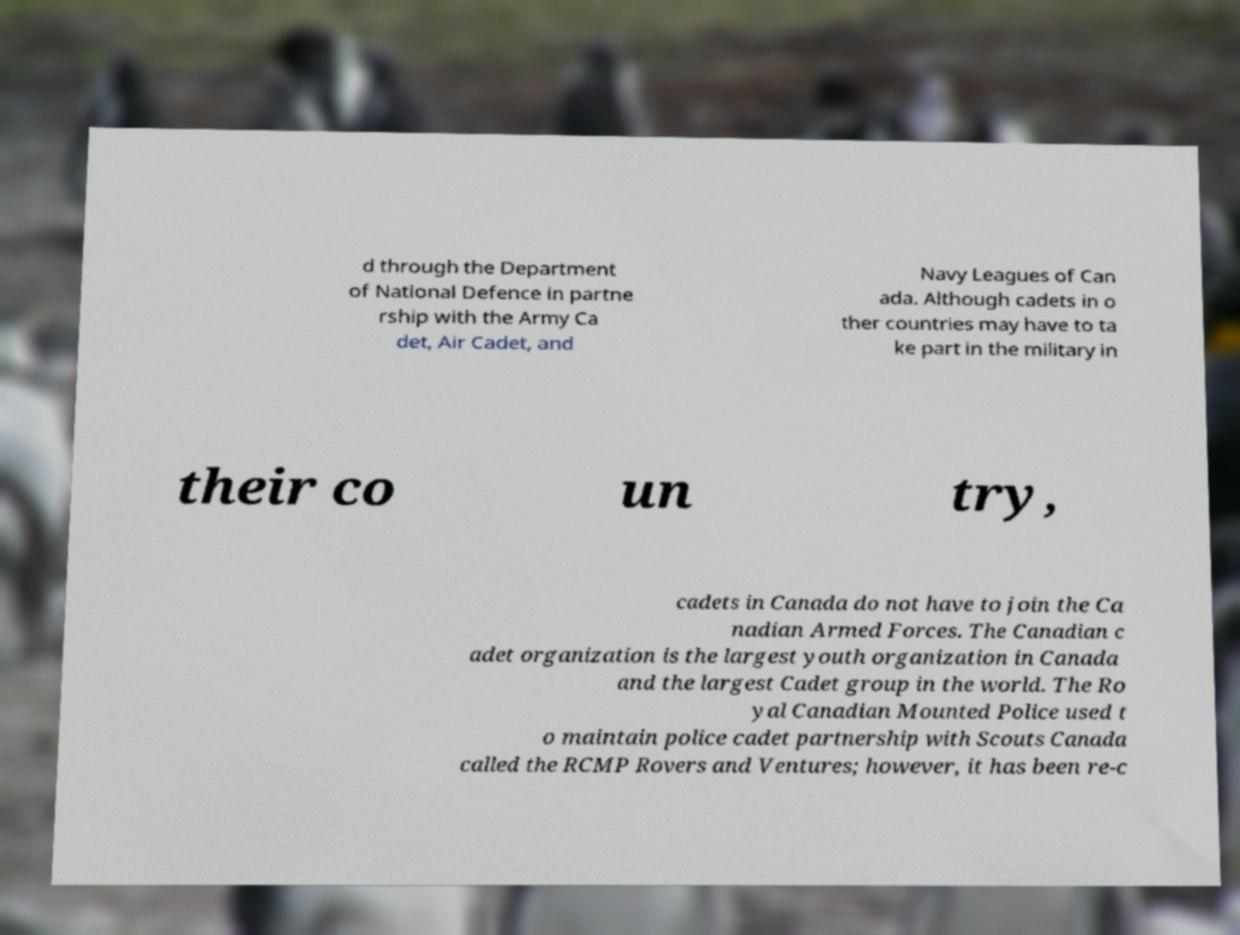Can you accurately transcribe the text from the provided image for me? d through the Department of National Defence in partne rship with the Army Ca det, Air Cadet, and Navy Leagues of Can ada. Although cadets in o ther countries may have to ta ke part in the military in their co un try, cadets in Canada do not have to join the Ca nadian Armed Forces. The Canadian c adet organization is the largest youth organization in Canada and the largest Cadet group in the world. The Ro yal Canadian Mounted Police used t o maintain police cadet partnership with Scouts Canada called the RCMP Rovers and Ventures; however, it has been re-c 